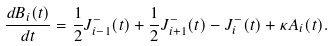<formula> <loc_0><loc_0><loc_500><loc_500>\frac { d B _ { i } ( t ) } { d t } = \frac { 1 } { 2 } J _ { i - 1 } ^ { - } ( t ) + \frac { 1 } { 2 } J _ { i + 1 } ^ { - } ( t ) - J _ { i } ^ { - } ( t ) + \kappa A _ { i } ( t ) .</formula> 